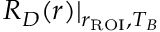Convert formula to latex. <formula><loc_0><loc_0><loc_500><loc_500>R _ { D } ( r ) | _ { r _ { R O I } , T _ { B } }</formula> 